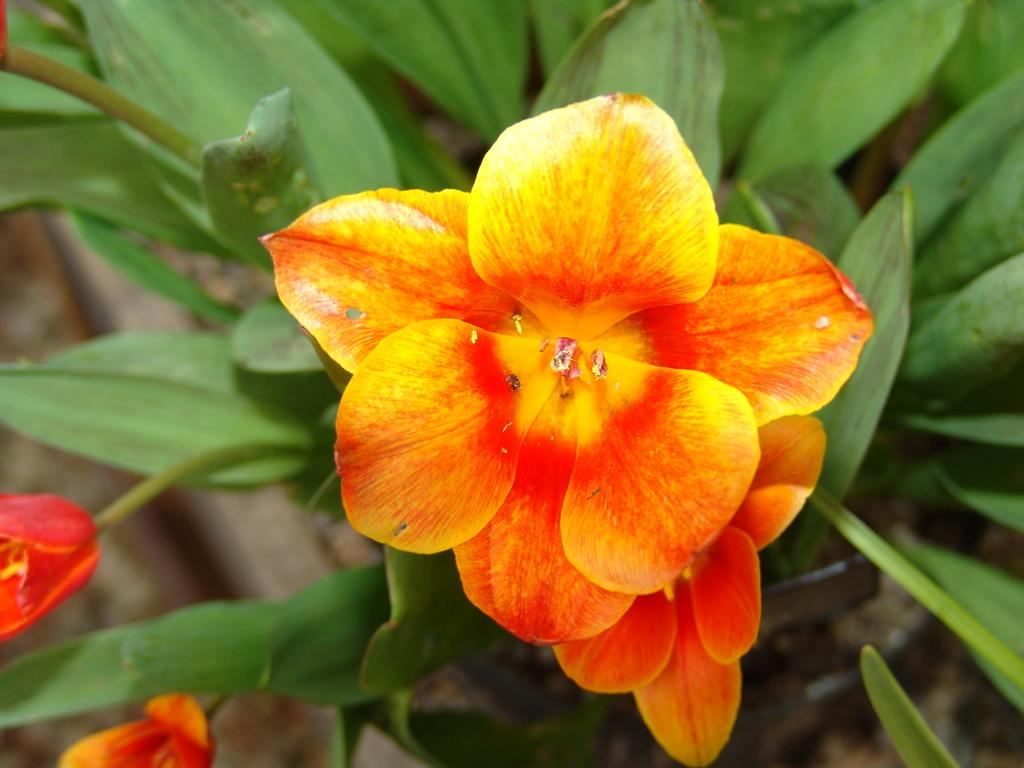What is present in the image? There is a plant in the image. What can be observed about the plant? The plant has flowers. What type of eggnog is being served with the plant in the image? There is no eggnog present in the image; it only features a plant with flowers. 